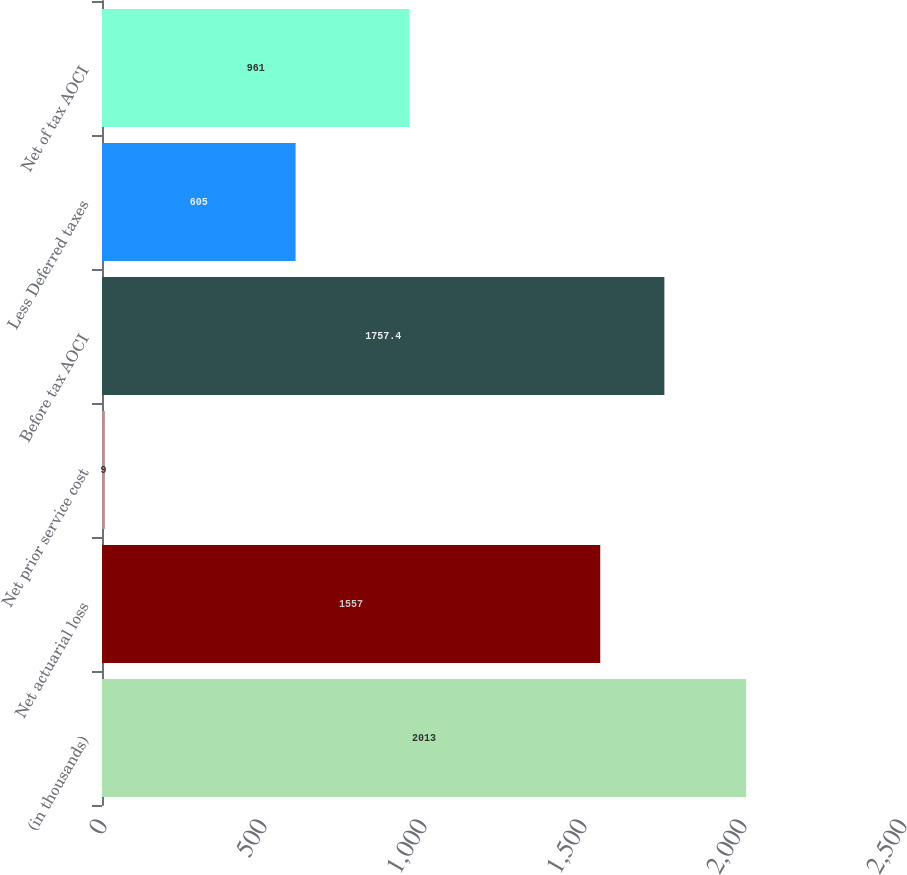Convert chart to OTSL. <chart><loc_0><loc_0><loc_500><loc_500><bar_chart><fcel>(in thousands)<fcel>Net actuarial loss<fcel>Net prior service cost<fcel>Before tax AOCI<fcel>Less Deferred taxes<fcel>Net of tax AOCI<nl><fcel>2013<fcel>1557<fcel>9<fcel>1757.4<fcel>605<fcel>961<nl></chart> 